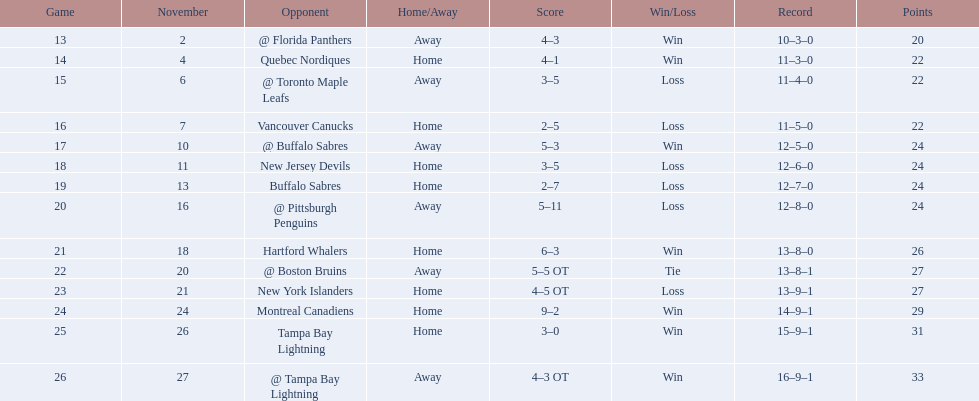What was the total penalty minutes that dave brown had on the 1993-1994 flyers? 137. 